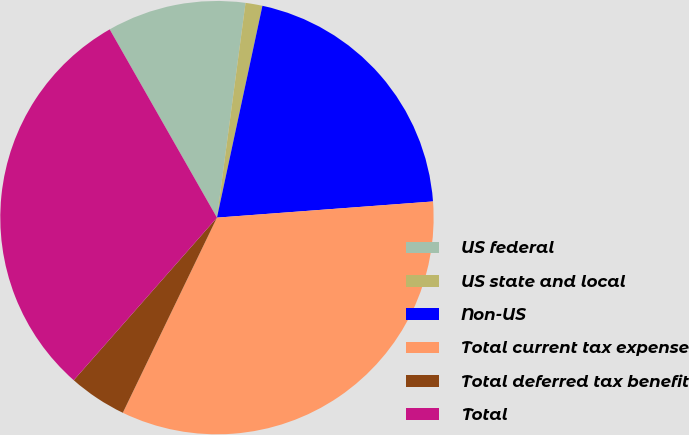<chart> <loc_0><loc_0><loc_500><loc_500><pie_chart><fcel>US federal<fcel>US state and local<fcel>Non-US<fcel>Total current tax expense<fcel>Total deferred tax benefit<fcel>Total<nl><fcel>10.35%<fcel>1.26%<fcel>20.45%<fcel>33.35%<fcel>4.34%<fcel>30.27%<nl></chart> 